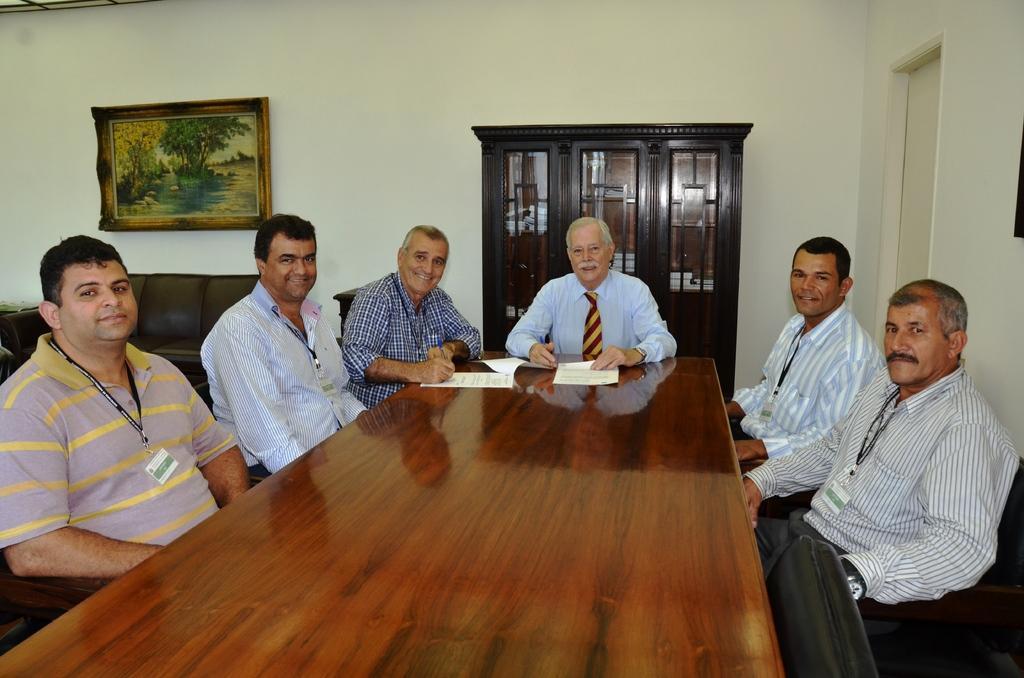Could you give a brief overview of what you see in this image? There are group of people sitting in front of a table and the background wall is white in color. 